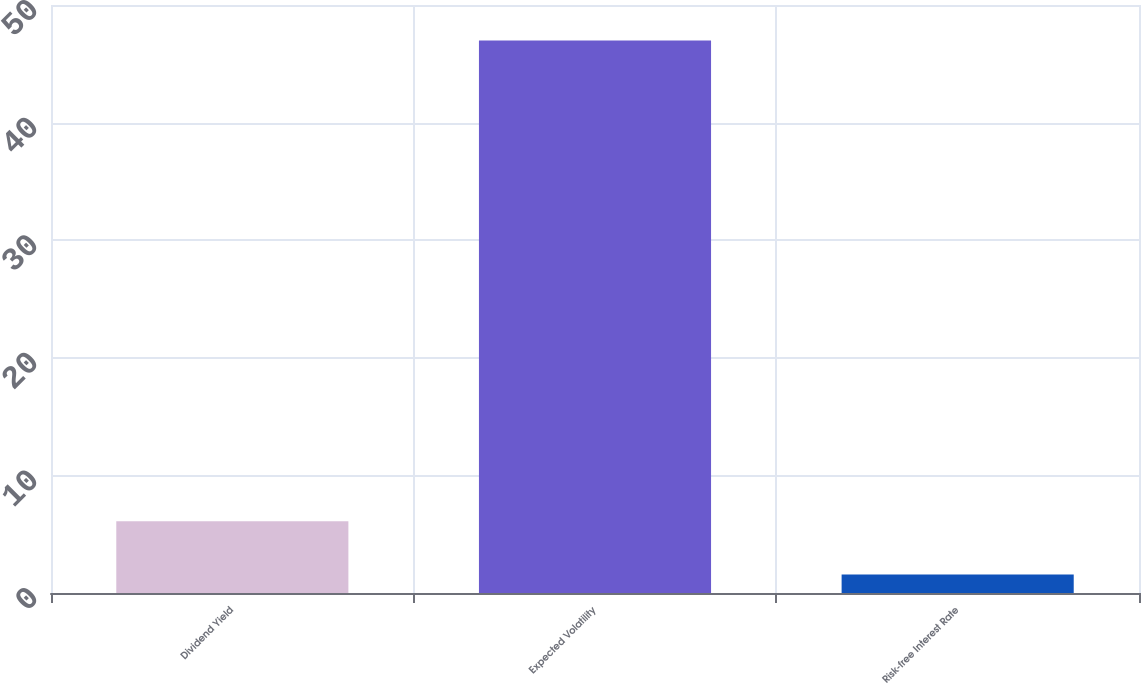Convert chart to OTSL. <chart><loc_0><loc_0><loc_500><loc_500><bar_chart><fcel>Dividend Yield<fcel>Expected Volatility<fcel>Risk-free Interest Rate<nl><fcel>6.11<fcel>46.99<fcel>1.57<nl></chart> 